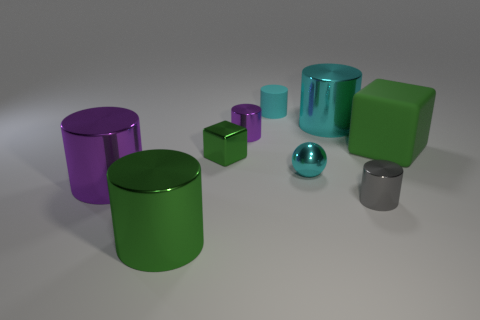Are there any other things that are the same material as the gray object?
Your response must be concise. Yes. Is the number of big cylinders that are right of the big cyan object less than the number of cyan matte things?
Your answer should be compact. Yes. Is the number of cyan cylinders in front of the large purple metal thing greater than the number of tiny purple objects that are in front of the metal cube?
Provide a short and direct response. No. Are there any other things of the same color as the small ball?
Your response must be concise. Yes. What is the material of the green object that is to the right of the gray thing?
Give a very brief answer. Rubber. Does the cyan sphere have the same size as the gray metal cylinder?
Make the answer very short. Yes. How many other objects are there of the same size as the cyan ball?
Keep it short and to the point. 4. Do the shiny sphere and the rubber cylinder have the same color?
Provide a succinct answer. Yes. What shape is the small cyan object that is in front of the tiny cylinder that is behind the big object behind the large green matte cube?
Provide a succinct answer. Sphere. What number of objects are either small cyan cylinders that are behind the large green cylinder or cyan things right of the cyan metal ball?
Keep it short and to the point. 2. 